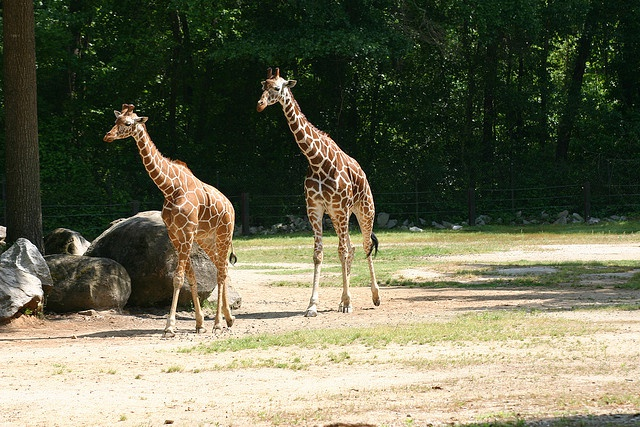Describe the objects in this image and their specific colors. I can see giraffe in black, ivory, maroon, brown, and tan tones and giraffe in black, tan, ivory, and maroon tones in this image. 